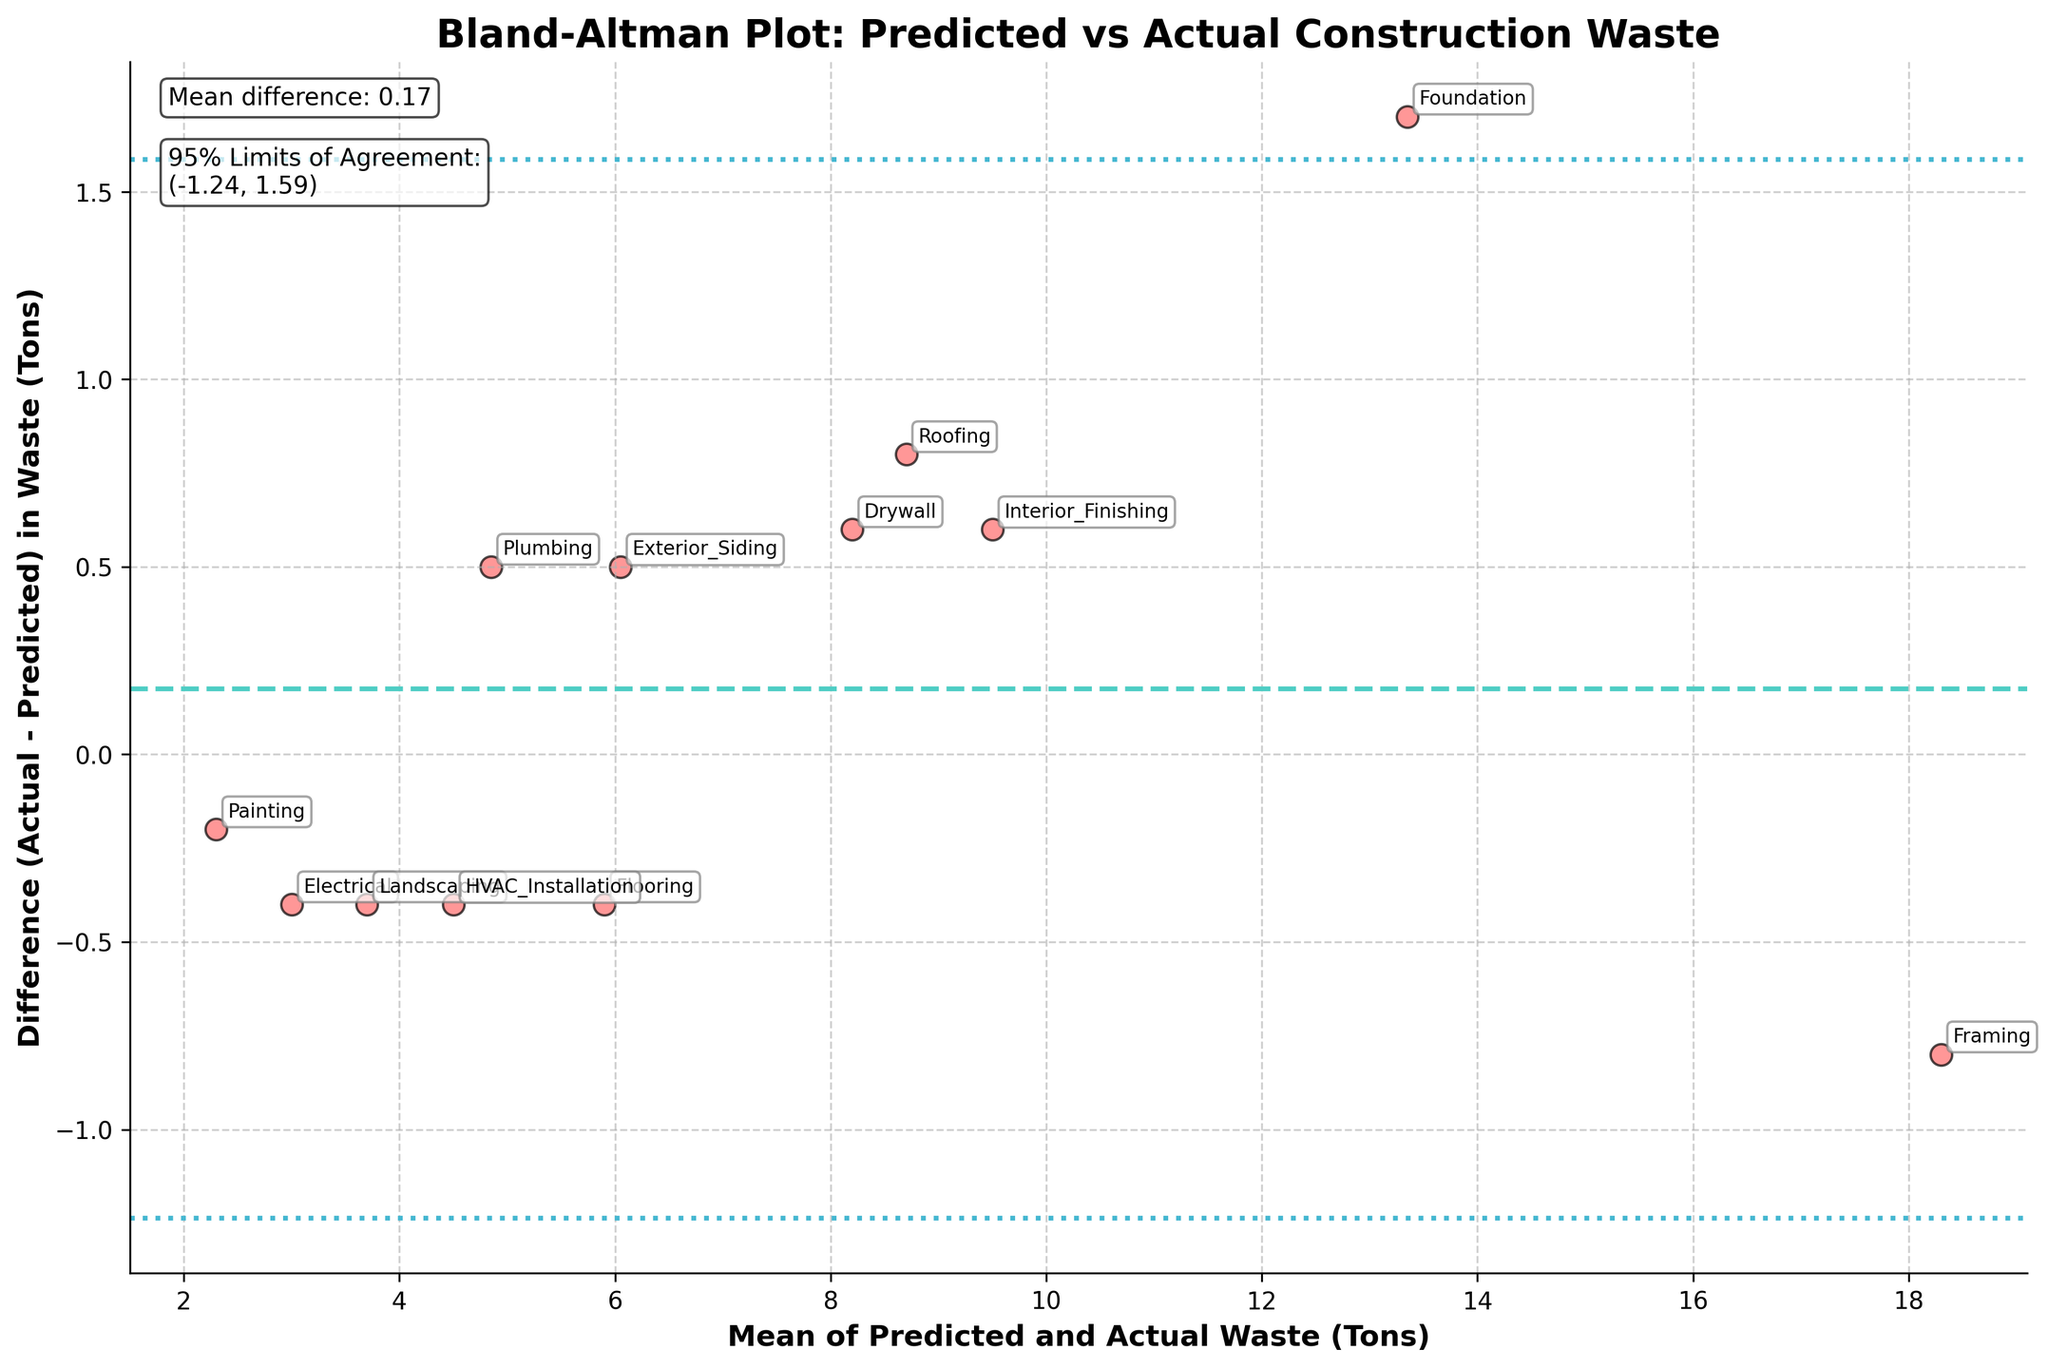What is the title of the plot? The title is usually located at the top of the figure. In this case, the title states the type of plot and the comparison being made.
Answer: Bland-Altman Plot: Predicted vs Actual Construction Waste How is the mean difference visually indicated in the plot? The mean difference is typically shown as a horizontal line across the plot. In this figure, there is a dashed line in a unique color that represents the mean difference.
Answer: A dashed line What are the 95% limits of agreement shown on the plot? Limits of agreement are usually represented by horizontal lines above and below the mean difference line. These lines are drawn in a different style than the mean difference line. Check the values annotated close to these lines.
Answer: From -0.80 to 1.50 Which construction phase has the largest positive difference between actual and predicted waste? The construction phase with the largest positive difference is found by looking at the plot for the point furthest above the mean difference line. Look at the annotations to identify the phase.
Answer: Foundation What is the mean of predicted and actual waste for Roofing in tons? Check the value of the mean of the predicted and actual waste for the Roofing phase by identifying its position on the x-axis and confirming against the annotations.
Answer: 8.70 tons Which construction phase is closest to having no difference between predicted and actual waste? This can be identified by looking for the point that lies closest to the horizontal axis at zero difference. Check the annotation to identify the phase.
Answer: HVAC Installation Do the differences between predicted and actual waste across phases cluster around the mean difference line? Determine if most data points are close to the mean difference line by checking their vertical positions relative to the mean difference line.
Answer: Yes How many construction phases have a negative difference between actual and predicted waste? Count the number of points below the mean difference line. Each point below indicates a negative difference.
Answer: Six What is the color used for the scatter points representing construction phases? Identify the color of the scatter points by observing the plot. The description mentions a specific color, often differentiated from other elements.
Answer: Red What is mentioned in the text box located in the top left corner of the plot? Locate the textbox and read its content. It generally provides statistical information like the mean difference and limits of agreement.
Answer: Mean difference: 0.35, 95% Limits of Agreement: (-0.80, 1.50) 